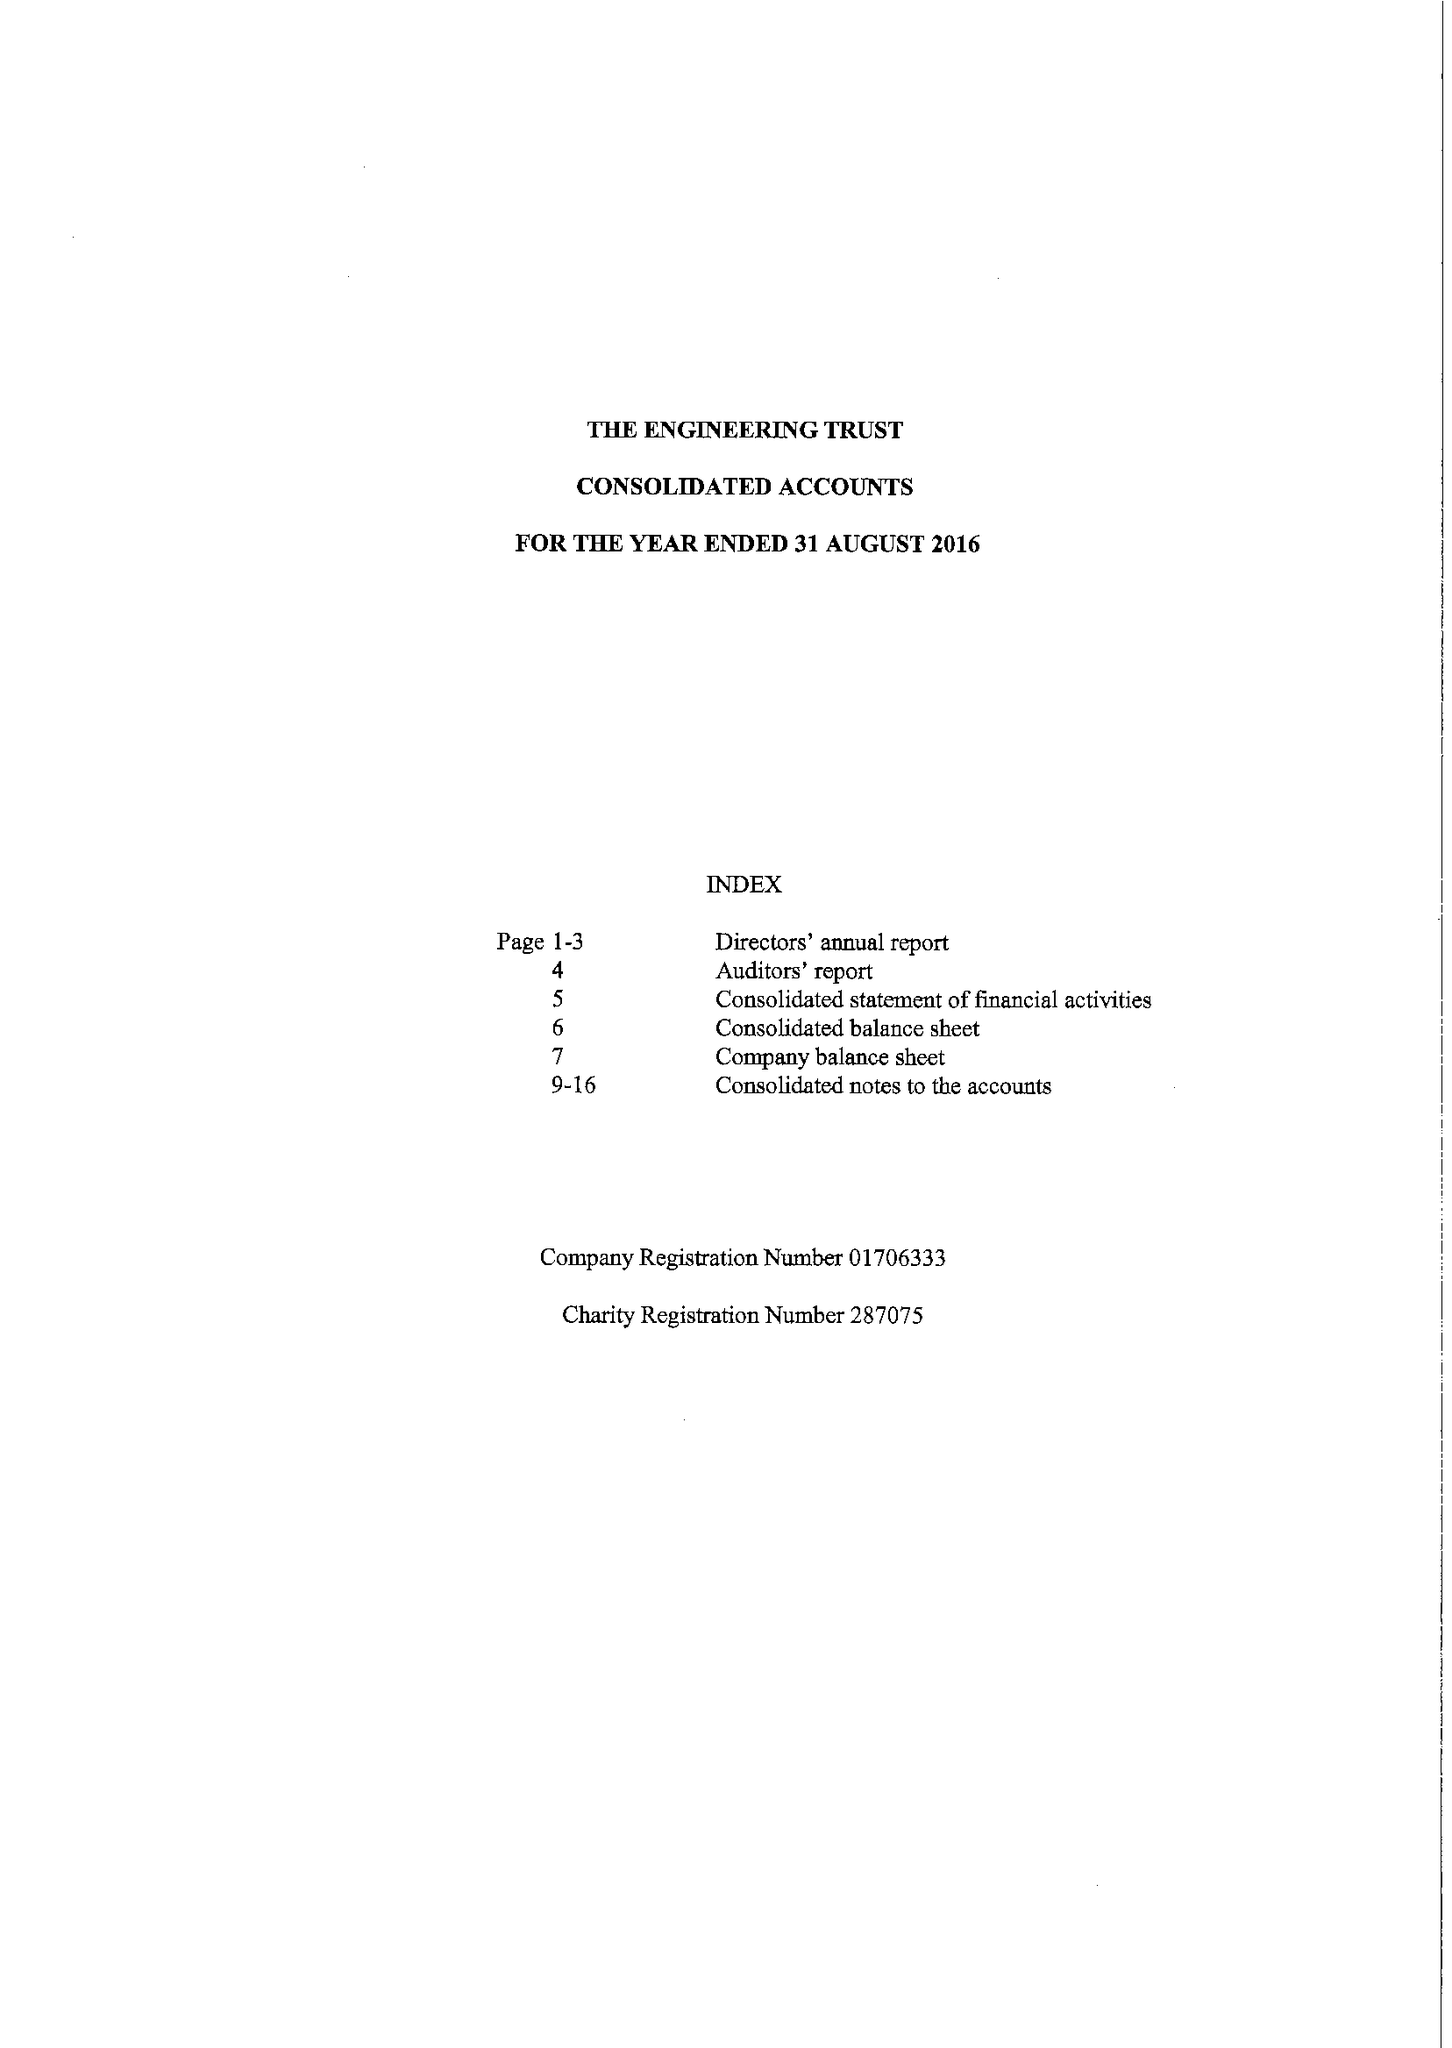What is the value for the charity_number?
Answer the question using a single word or phrase. 287075 